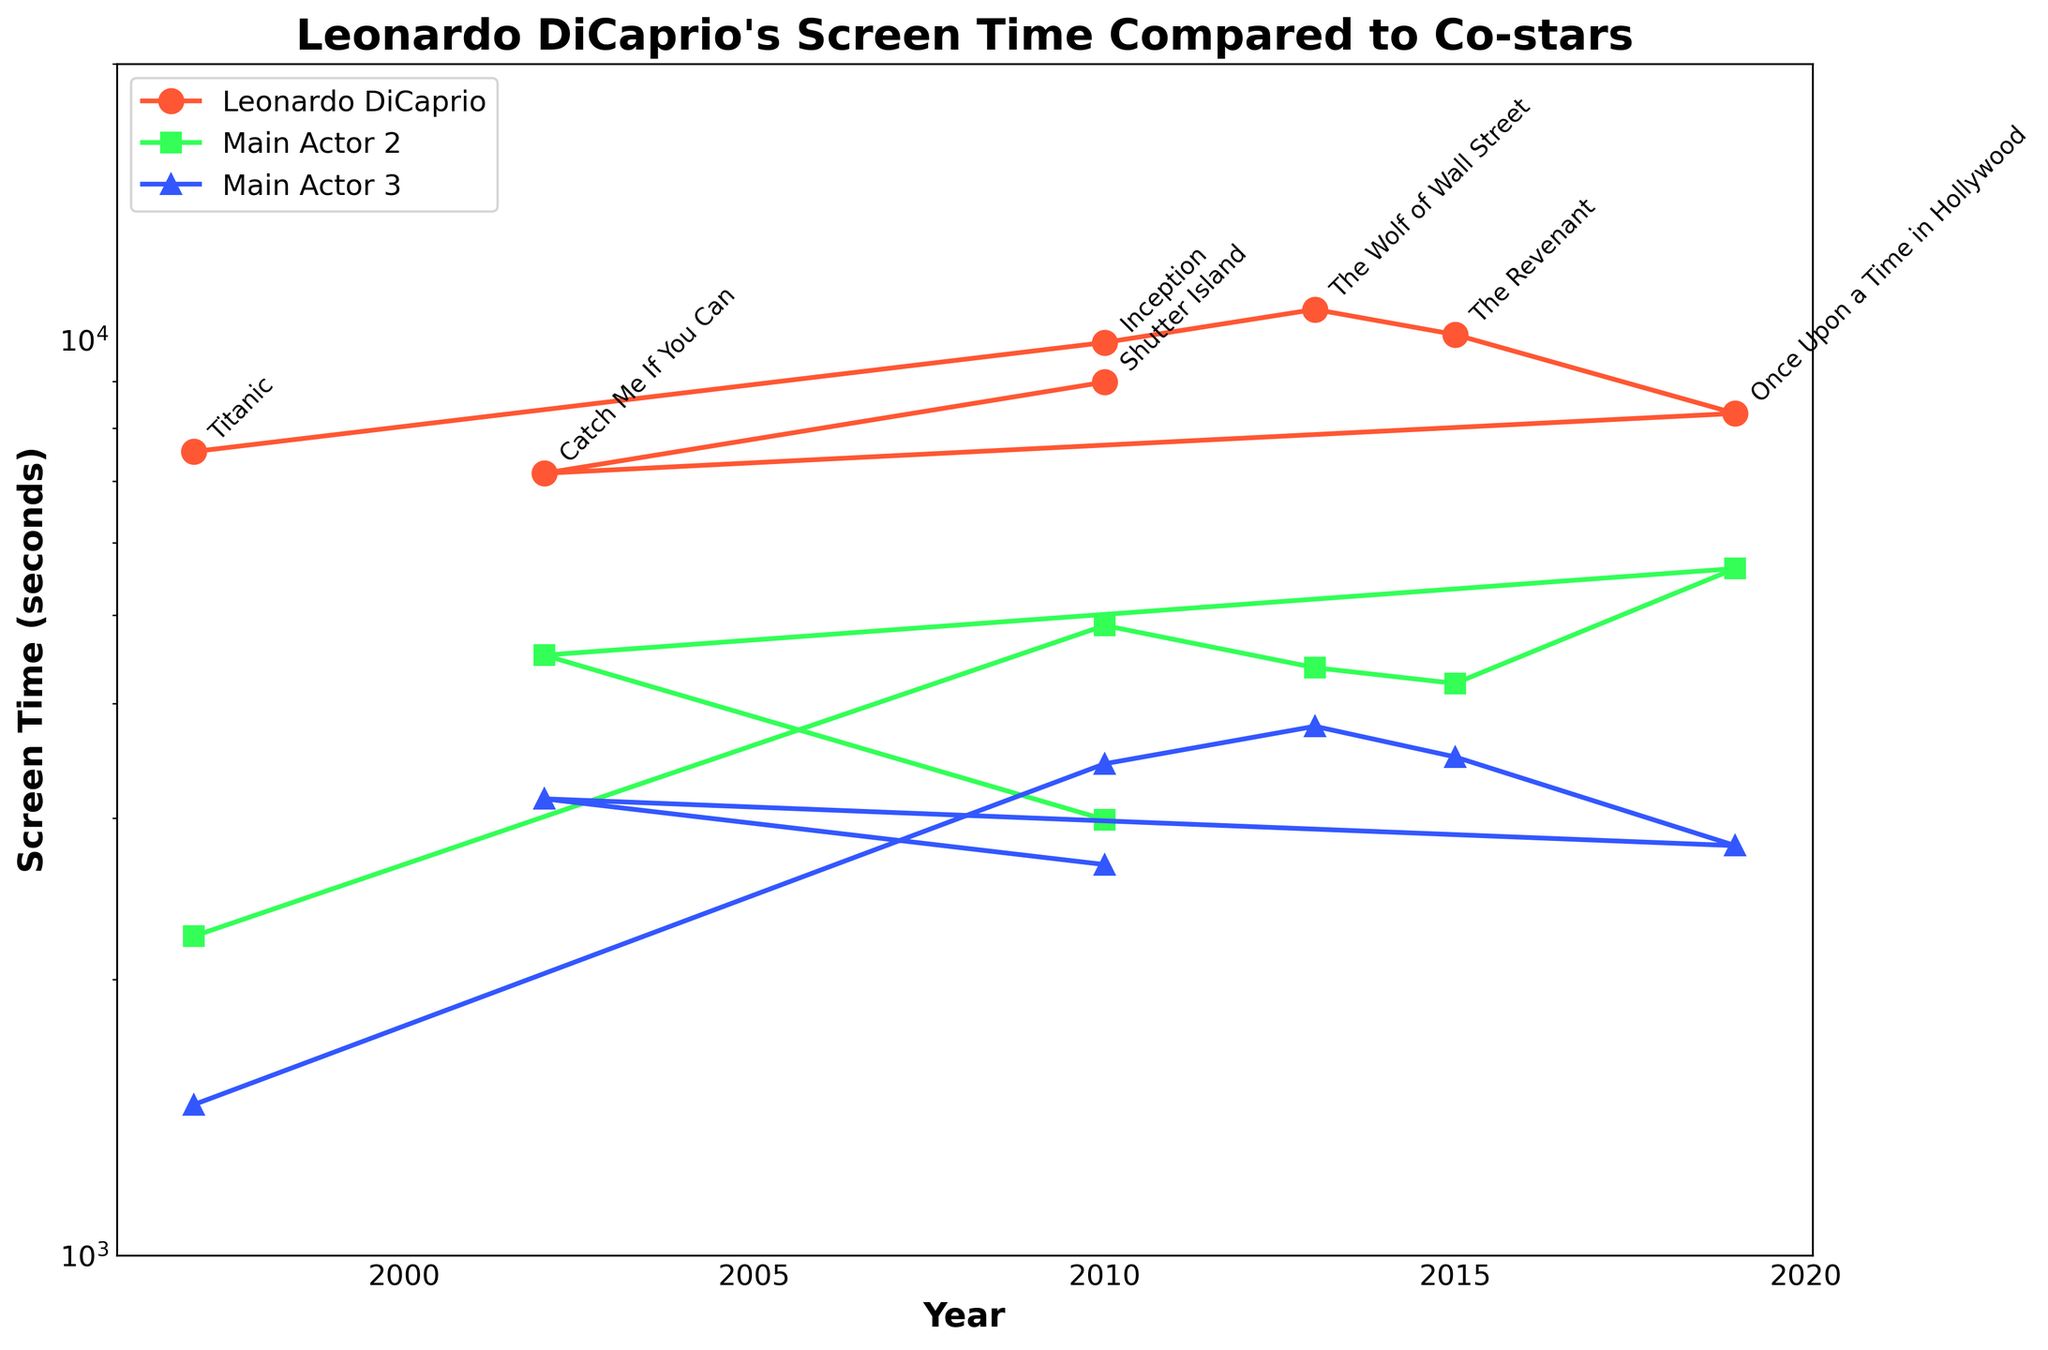What's the title of the plot? The title of the plot is displayed at the top of the figure in larger font.
Answer: Leonardo DiCaprio's Screen Time Compared to Co-stars What is the y-axis scale of the plot? The y-axis scale is indicated on the axis labels, which show a logarithmic scale progression (e.g., 1000, 2000, 5000, etc.).
Answer: Logarithmic Which movie has the highest screen time for Leonardo DiCaprio? Compare Leonardo DiCaprio's screen time for each movie by looking for the highest point on the orange line in the plot.
Answer: The Wolf of Wall Street What's the general trend of Leonardo DiCaprio's screen time over the years? Analyze the progression of the orange line representing Leonardo DiCaprio's screen time across different years to observe the trend.
Answer: Increasing trend in screen time In which year was Leonardo DiCaprio's screen time the lowest? Identify the lowest point on the orange line and its corresponding year on the x-axis.
Answer: 2002 (Catch Me If You Can) How does Leonardo DiCaprio's screen time in "Inception" compare to that of Main Actor 2 and Main Actor 3? Compare the y-value of Leonardo DiCaprio's point to those of Main Actor 2 and Main Actor 3 for the same year (2010).
Answer: Higher than both Main Actor 2 and Main Actor 3 What is the difference in screen time between Leonardo DiCaprio and Main Actor 2 in "Once Upon a Time in Hollywood"? Subtract Main Actor 2's screen time from Leonardo DiCaprio's screen time for the year 2019.
Answer: 2680 seconds Which movie involved the smallest difference in screen time between Leonardo DiCaprio and Main Actor 3? Calculate the differences in screen time for each movie, and then find the smallest value.
Answer: Titanic Which co-star has the highest screen time in "Shutter Island"? Compare the screen times of Main Actor 2 and Main Actor 3 for the year 2010.
Answer: Main Actor 2 Is Leonardo DiCaprio's screen time always higher than that of Main Actor 2 in all the movies? Check each data point on Leonardo DiCaprio's line and compare its value to the corresponding data point on Main Actor 2's line.
Answer: No 